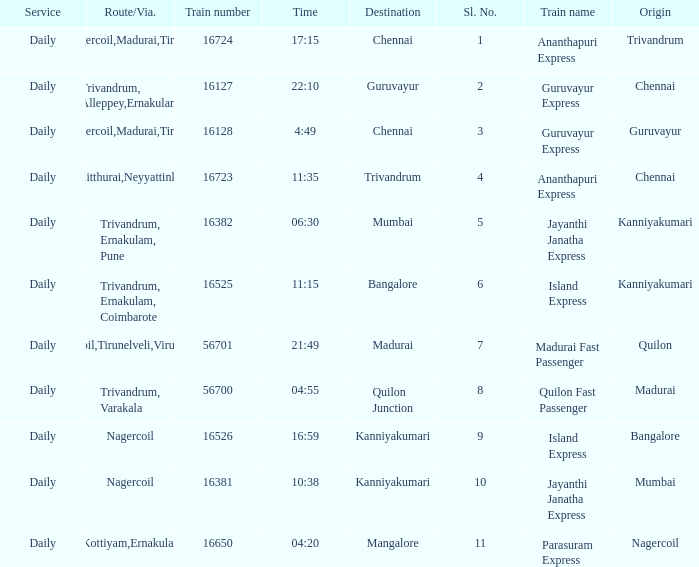What is the origin when the destination is Mumbai? Kanniyakumari. 